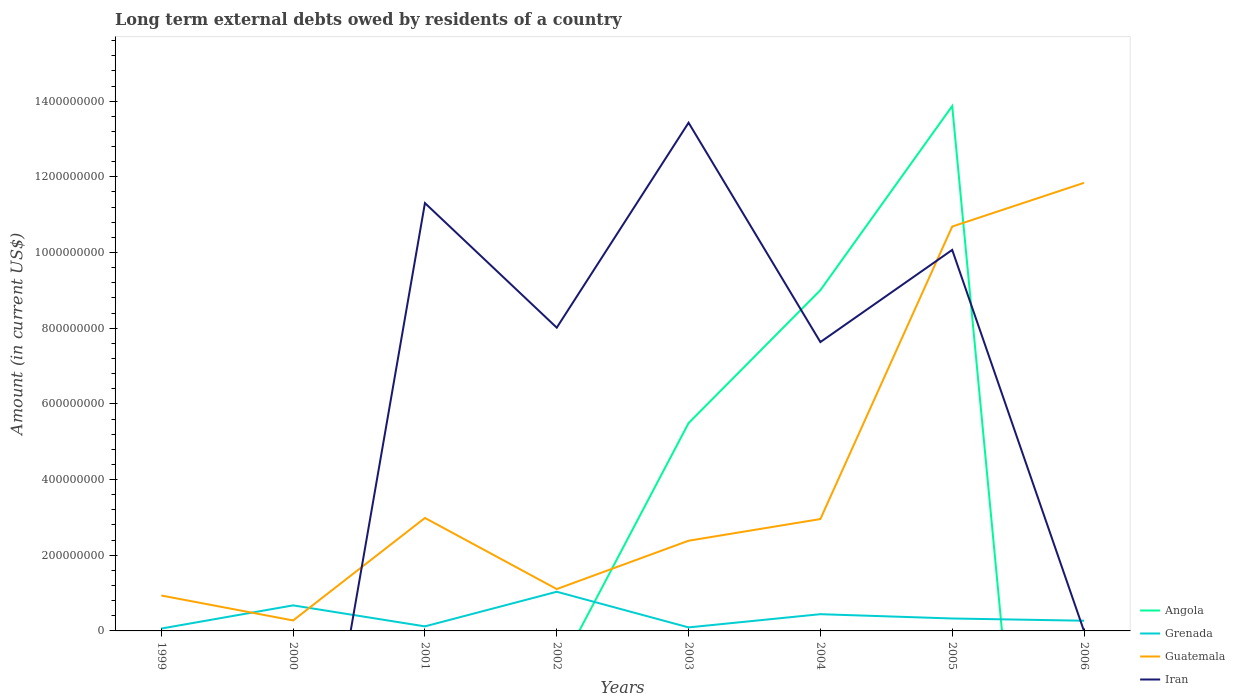Across all years, what is the maximum amount of long-term external debts owed by residents in Guatemala?
Your answer should be compact. 2.76e+07. What is the total amount of long-term external debts owed by residents in Iran in the graph?
Ensure brevity in your answer.  1.24e+08. What is the difference between the highest and the second highest amount of long-term external debts owed by residents in Guatemala?
Offer a very short reply. 1.16e+09. How many lines are there?
Your answer should be very brief. 4. How many years are there in the graph?
Offer a terse response. 8. Does the graph contain any zero values?
Ensure brevity in your answer.  Yes. How many legend labels are there?
Offer a very short reply. 4. How are the legend labels stacked?
Ensure brevity in your answer.  Vertical. What is the title of the graph?
Offer a terse response. Long term external debts owed by residents of a country. Does "Moldova" appear as one of the legend labels in the graph?
Your response must be concise. No. What is the label or title of the X-axis?
Your answer should be compact. Years. What is the label or title of the Y-axis?
Your answer should be compact. Amount (in current US$). What is the Amount (in current US$) of Angola in 1999?
Provide a succinct answer. 0. What is the Amount (in current US$) of Grenada in 1999?
Make the answer very short. 6.29e+06. What is the Amount (in current US$) in Guatemala in 1999?
Your answer should be very brief. 9.36e+07. What is the Amount (in current US$) in Iran in 1999?
Your answer should be compact. 0. What is the Amount (in current US$) of Angola in 2000?
Provide a succinct answer. 0. What is the Amount (in current US$) of Grenada in 2000?
Make the answer very short. 6.75e+07. What is the Amount (in current US$) in Guatemala in 2000?
Ensure brevity in your answer.  2.76e+07. What is the Amount (in current US$) in Iran in 2000?
Make the answer very short. 0. What is the Amount (in current US$) in Grenada in 2001?
Keep it short and to the point. 1.20e+07. What is the Amount (in current US$) of Guatemala in 2001?
Your answer should be very brief. 2.99e+08. What is the Amount (in current US$) in Iran in 2001?
Provide a succinct answer. 1.13e+09. What is the Amount (in current US$) in Grenada in 2002?
Provide a short and direct response. 1.04e+08. What is the Amount (in current US$) in Guatemala in 2002?
Give a very brief answer. 1.11e+08. What is the Amount (in current US$) of Iran in 2002?
Provide a succinct answer. 8.01e+08. What is the Amount (in current US$) in Angola in 2003?
Your answer should be very brief. 5.49e+08. What is the Amount (in current US$) in Grenada in 2003?
Provide a succinct answer. 9.30e+06. What is the Amount (in current US$) in Guatemala in 2003?
Provide a succinct answer. 2.38e+08. What is the Amount (in current US$) in Iran in 2003?
Your answer should be compact. 1.34e+09. What is the Amount (in current US$) in Angola in 2004?
Your response must be concise. 9.00e+08. What is the Amount (in current US$) in Grenada in 2004?
Make the answer very short. 4.42e+07. What is the Amount (in current US$) of Guatemala in 2004?
Your response must be concise. 2.96e+08. What is the Amount (in current US$) of Iran in 2004?
Offer a terse response. 7.63e+08. What is the Amount (in current US$) in Angola in 2005?
Your response must be concise. 1.39e+09. What is the Amount (in current US$) in Grenada in 2005?
Give a very brief answer. 3.29e+07. What is the Amount (in current US$) in Guatemala in 2005?
Offer a terse response. 1.07e+09. What is the Amount (in current US$) of Iran in 2005?
Your response must be concise. 1.01e+09. What is the Amount (in current US$) in Grenada in 2006?
Provide a short and direct response. 2.70e+07. What is the Amount (in current US$) in Guatemala in 2006?
Ensure brevity in your answer.  1.18e+09. What is the Amount (in current US$) in Iran in 2006?
Give a very brief answer. 0. Across all years, what is the maximum Amount (in current US$) of Angola?
Make the answer very short. 1.39e+09. Across all years, what is the maximum Amount (in current US$) of Grenada?
Offer a terse response. 1.04e+08. Across all years, what is the maximum Amount (in current US$) of Guatemala?
Your answer should be very brief. 1.18e+09. Across all years, what is the maximum Amount (in current US$) of Iran?
Make the answer very short. 1.34e+09. Across all years, what is the minimum Amount (in current US$) of Angola?
Offer a terse response. 0. Across all years, what is the minimum Amount (in current US$) in Grenada?
Ensure brevity in your answer.  6.29e+06. Across all years, what is the minimum Amount (in current US$) in Guatemala?
Offer a very short reply. 2.76e+07. Across all years, what is the minimum Amount (in current US$) of Iran?
Your response must be concise. 0. What is the total Amount (in current US$) of Angola in the graph?
Ensure brevity in your answer.  2.84e+09. What is the total Amount (in current US$) of Grenada in the graph?
Make the answer very short. 3.03e+08. What is the total Amount (in current US$) of Guatemala in the graph?
Ensure brevity in your answer.  3.32e+09. What is the total Amount (in current US$) of Iran in the graph?
Provide a succinct answer. 5.05e+09. What is the difference between the Amount (in current US$) of Grenada in 1999 and that in 2000?
Your answer should be compact. -6.12e+07. What is the difference between the Amount (in current US$) of Guatemala in 1999 and that in 2000?
Offer a terse response. 6.60e+07. What is the difference between the Amount (in current US$) of Grenada in 1999 and that in 2001?
Offer a terse response. -5.71e+06. What is the difference between the Amount (in current US$) in Guatemala in 1999 and that in 2001?
Your response must be concise. -2.05e+08. What is the difference between the Amount (in current US$) in Grenada in 1999 and that in 2002?
Keep it short and to the point. -9.72e+07. What is the difference between the Amount (in current US$) in Guatemala in 1999 and that in 2002?
Provide a succinct answer. -1.70e+07. What is the difference between the Amount (in current US$) in Grenada in 1999 and that in 2003?
Ensure brevity in your answer.  -3.01e+06. What is the difference between the Amount (in current US$) of Guatemala in 1999 and that in 2003?
Your answer should be compact. -1.45e+08. What is the difference between the Amount (in current US$) of Grenada in 1999 and that in 2004?
Provide a short and direct response. -3.79e+07. What is the difference between the Amount (in current US$) in Guatemala in 1999 and that in 2004?
Offer a terse response. -2.02e+08. What is the difference between the Amount (in current US$) in Grenada in 1999 and that in 2005?
Your answer should be very brief. -2.66e+07. What is the difference between the Amount (in current US$) of Guatemala in 1999 and that in 2005?
Keep it short and to the point. -9.75e+08. What is the difference between the Amount (in current US$) of Grenada in 1999 and that in 2006?
Provide a short and direct response. -2.07e+07. What is the difference between the Amount (in current US$) of Guatemala in 1999 and that in 2006?
Give a very brief answer. -1.09e+09. What is the difference between the Amount (in current US$) in Grenada in 2000 and that in 2001?
Your response must be concise. 5.55e+07. What is the difference between the Amount (in current US$) of Guatemala in 2000 and that in 2001?
Give a very brief answer. -2.71e+08. What is the difference between the Amount (in current US$) of Grenada in 2000 and that in 2002?
Your answer should be very brief. -3.60e+07. What is the difference between the Amount (in current US$) of Guatemala in 2000 and that in 2002?
Ensure brevity in your answer.  -8.30e+07. What is the difference between the Amount (in current US$) of Grenada in 2000 and that in 2003?
Your answer should be compact. 5.82e+07. What is the difference between the Amount (in current US$) in Guatemala in 2000 and that in 2003?
Ensure brevity in your answer.  -2.11e+08. What is the difference between the Amount (in current US$) in Grenada in 2000 and that in 2004?
Your answer should be compact. 2.33e+07. What is the difference between the Amount (in current US$) in Guatemala in 2000 and that in 2004?
Give a very brief answer. -2.68e+08. What is the difference between the Amount (in current US$) in Grenada in 2000 and that in 2005?
Provide a succinct answer. 3.46e+07. What is the difference between the Amount (in current US$) of Guatemala in 2000 and that in 2005?
Make the answer very short. -1.04e+09. What is the difference between the Amount (in current US$) in Grenada in 2000 and that in 2006?
Your answer should be very brief. 4.05e+07. What is the difference between the Amount (in current US$) of Guatemala in 2000 and that in 2006?
Provide a short and direct response. -1.16e+09. What is the difference between the Amount (in current US$) of Grenada in 2001 and that in 2002?
Your answer should be compact. -9.15e+07. What is the difference between the Amount (in current US$) in Guatemala in 2001 and that in 2002?
Provide a short and direct response. 1.88e+08. What is the difference between the Amount (in current US$) of Iran in 2001 and that in 2002?
Offer a very short reply. 3.29e+08. What is the difference between the Amount (in current US$) of Grenada in 2001 and that in 2003?
Offer a terse response. 2.70e+06. What is the difference between the Amount (in current US$) in Guatemala in 2001 and that in 2003?
Provide a succinct answer. 6.02e+07. What is the difference between the Amount (in current US$) in Iran in 2001 and that in 2003?
Offer a very short reply. -2.12e+08. What is the difference between the Amount (in current US$) of Grenada in 2001 and that in 2004?
Your answer should be compact. -3.22e+07. What is the difference between the Amount (in current US$) in Guatemala in 2001 and that in 2004?
Ensure brevity in your answer.  2.89e+06. What is the difference between the Amount (in current US$) in Iran in 2001 and that in 2004?
Give a very brief answer. 3.67e+08. What is the difference between the Amount (in current US$) in Grenada in 2001 and that in 2005?
Keep it short and to the point. -2.09e+07. What is the difference between the Amount (in current US$) in Guatemala in 2001 and that in 2005?
Offer a very short reply. -7.70e+08. What is the difference between the Amount (in current US$) in Iran in 2001 and that in 2005?
Your answer should be compact. 1.24e+08. What is the difference between the Amount (in current US$) in Grenada in 2001 and that in 2006?
Your answer should be compact. -1.50e+07. What is the difference between the Amount (in current US$) in Guatemala in 2001 and that in 2006?
Your response must be concise. -8.86e+08. What is the difference between the Amount (in current US$) of Grenada in 2002 and that in 2003?
Your answer should be compact. 9.42e+07. What is the difference between the Amount (in current US$) in Guatemala in 2002 and that in 2003?
Offer a terse response. -1.28e+08. What is the difference between the Amount (in current US$) in Iran in 2002 and that in 2003?
Your answer should be very brief. -5.42e+08. What is the difference between the Amount (in current US$) of Grenada in 2002 and that in 2004?
Provide a short and direct response. 5.93e+07. What is the difference between the Amount (in current US$) of Guatemala in 2002 and that in 2004?
Your response must be concise. -1.85e+08. What is the difference between the Amount (in current US$) of Iran in 2002 and that in 2004?
Your response must be concise. 3.81e+07. What is the difference between the Amount (in current US$) in Grenada in 2002 and that in 2005?
Ensure brevity in your answer.  7.07e+07. What is the difference between the Amount (in current US$) of Guatemala in 2002 and that in 2005?
Provide a short and direct response. -9.58e+08. What is the difference between the Amount (in current US$) in Iran in 2002 and that in 2005?
Ensure brevity in your answer.  -2.05e+08. What is the difference between the Amount (in current US$) in Grenada in 2002 and that in 2006?
Provide a succinct answer. 7.66e+07. What is the difference between the Amount (in current US$) in Guatemala in 2002 and that in 2006?
Make the answer very short. -1.07e+09. What is the difference between the Amount (in current US$) of Angola in 2003 and that in 2004?
Ensure brevity in your answer.  -3.51e+08. What is the difference between the Amount (in current US$) in Grenada in 2003 and that in 2004?
Ensure brevity in your answer.  -3.49e+07. What is the difference between the Amount (in current US$) of Guatemala in 2003 and that in 2004?
Ensure brevity in your answer.  -5.73e+07. What is the difference between the Amount (in current US$) in Iran in 2003 and that in 2004?
Provide a succinct answer. 5.80e+08. What is the difference between the Amount (in current US$) of Angola in 2003 and that in 2005?
Give a very brief answer. -8.38e+08. What is the difference between the Amount (in current US$) in Grenada in 2003 and that in 2005?
Offer a very short reply. -2.36e+07. What is the difference between the Amount (in current US$) of Guatemala in 2003 and that in 2005?
Provide a short and direct response. -8.30e+08. What is the difference between the Amount (in current US$) in Iran in 2003 and that in 2005?
Make the answer very short. 3.36e+08. What is the difference between the Amount (in current US$) of Grenada in 2003 and that in 2006?
Your response must be concise. -1.77e+07. What is the difference between the Amount (in current US$) of Guatemala in 2003 and that in 2006?
Ensure brevity in your answer.  -9.46e+08. What is the difference between the Amount (in current US$) of Angola in 2004 and that in 2005?
Offer a very short reply. -4.87e+08. What is the difference between the Amount (in current US$) in Grenada in 2004 and that in 2005?
Your answer should be compact. 1.14e+07. What is the difference between the Amount (in current US$) in Guatemala in 2004 and that in 2005?
Provide a succinct answer. -7.73e+08. What is the difference between the Amount (in current US$) of Iran in 2004 and that in 2005?
Provide a succinct answer. -2.44e+08. What is the difference between the Amount (in current US$) of Grenada in 2004 and that in 2006?
Provide a short and direct response. 1.73e+07. What is the difference between the Amount (in current US$) of Guatemala in 2004 and that in 2006?
Your answer should be very brief. -8.88e+08. What is the difference between the Amount (in current US$) of Grenada in 2005 and that in 2006?
Offer a terse response. 5.89e+06. What is the difference between the Amount (in current US$) of Guatemala in 2005 and that in 2006?
Your answer should be very brief. -1.16e+08. What is the difference between the Amount (in current US$) in Grenada in 1999 and the Amount (in current US$) in Guatemala in 2000?
Keep it short and to the point. -2.13e+07. What is the difference between the Amount (in current US$) of Grenada in 1999 and the Amount (in current US$) of Guatemala in 2001?
Your response must be concise. -2.92e+08. What is the difference between the Amount (in current US$) of Grenada in 1999 and the Amount (in current US$) of Iran in 2001?
Provide a succinct answer. -1.12e+09. What is the difference between the Amount (in current US$) in Guatemala in 1999 and the Amount (in current US$) in Iran in 2001?
Your response must be concise. -1.04e+09. What is the difference between the Amount (in current US$) of Grenada in 1999 and the Amount (in current US$) of Guatemala in 2002?
Provide a short and direct response. -1.04e+08. What is the difference between the Amount (in current US$) in Grenada in 1999 and the Amount (in current US$) in Iran in 2002?
Provide a short and direct response. -7.95e+08. What is the difference between the Amount (in current US$) of Guatemala in 1999 and the Amount (in current US$) of Iran in 2002?
Provide a succinct answer. -7.08e+08. What is the difference between the Amount (in current US$) of Grenada in 1999 and the Amount (in current US$) of Guatemala in 2003?
Make the answer very short. -2.32e+08. What is the difference between the Amount (in current US$) in Grenada in 1999 and the Amount (in current US$) in Iran in 2003?
Offer a very short reply. -1.34e+09. What is the difference between the Amount (in current US$) in Guatemala in 1999 and the Amount (in current US$) in Iran in 2003?
Your response must be concise. -1.25e+09. What is the difference between the Amount (in current US$) in Grenada in 1999 and the Amount (in current US$) in Guatemala in 2004?
Provide a short and direct response. -2.89e+08. What is the difference between the Amount (in current US$) in Grenada in 1999 and the Amount (in current US$) in Iran in 2004?
Keep it short and to the point. -7.57e+08. What is the difference between the Amount (in current US$) in Guatemala in 1999 and the Amount (in current US$) in Iran in 2004?
Ensure brevity in your answer.  -6.70e+08. What is the difference between the Amount (in current US$) of Grenada in 1999 and the Amount (in current US$) of Guatemala in 2005?
Make the answer very short. -1.06e+09. What is the difference between the Amount (in current US$) in Grenada in 1999 and the Amount (in current US$) in Iran in 2005?
Your answer should be very brief. -1.00e+09. What is the difference between the Amount (in current US$) of Guatemala in 1999 and the Amount (in current US$) of Iran in 2005?
Keep it short and to the point. -9.13e+08. What is the difference between the Amount (in current US$) of Grenada in 1999 and the Amount (in current US$) of Guatemala in 2006?
Keep it short and to the point. -1.18e+09. What is the difference between the Amount (in current US$) in Grenada in 2000 and the Amount (in current US$) in Guatemala in 2001?
Provide a short and direct response. -2.31e+08. What is the difference between the Amount (in current US$) in Grenada in 2000 and the Amount (in current US$) in Iran in 2001?
Make the answer very short. -1.06e+09. What is the difference between the Amount (in current US$) of Guatemala in 2000 and the Amount (in current US$) of Iran in 2001?
Give a very brief answer. -1.10e+09. What is the difference between the Amount (in current US$) of Grenada in 2000 and the Amount (in current US$) of Guatemala in 2002?
Give a very brief answer. -4.31e+07. What is the difference between the Amount (in current US$) in Grenada in 2000 and the Amount (in current US$) in Iran in 2002?
Ensure brevity in your answer.  -7.34e+08. What is the difference between the Amount (in current US$) in Guatemala in 2000 and the Amount (in current US$) in Iran in 2002?
Your answer should be very brief. -7.74e+08. What is the difference between the Amount (in current US$) in Grenada in 2000 and the Amount (in current US$) in Guatemala in 2003?
Your response must be concise. -1.71e+08. What is the difference between the Amount (in current US$) in Grenada in 2000 and the Amount (in current US$) in Iran in 2003?
Your answer should be very brief. -1.28e+09. What is the difference between the Amount (in current US$) of Guatemala in 2000 and the Amount (in current US$) of Iran in 2003?
Make the answer very short. -1.32e+09. What is the difference between the Amount (in current US$) of Grenada in 2000 and the Amount (in current US$) of Guatemala in 2004?
Give a very brief answer. -2.28e+08. What is the difference between the Amount (in current US$) of Grenada in 2000 and the Amount (in current US$) of Iran in 2004?
Provide a succinct answer. -6.96e+08. What is the difference between the Amount (in current US$) in Guatemala in 2000 and the Amount (in current US$) in Iran in 2004?
Your answer should be very brief. -7.36e+08. What is the difference between the Amount (in current US$) in Grenada in 2000 and the Amount (in current US$) in Guatemala in 2005?
Give a very brief answer. -1.00e+09. What is the difference between the Amount (in current US$) in Grenada in 2000 and the Amount (in current US$) in Iran in 2005?
Offer a very short reply. -9.39e+08. What is the difference between the Amount (in current US$) in Guatemala in 2000 and the Amount (in current US$) in Iran in 2005?
Offer a very short reply. -9.79e+08. What is the difference between the Amount (in current US$) of Grenada in 2000 and the Amount (in current US$) of Guatemala in 2006?
Your answer should be compact. -1.12e+09. What is the difference between the Amount (in current US$) of Grenada in 2001 and the Amount (in current US$) of Guatemala in 2002?
Give a very brief answer. -9.86e+07. What is the difference between the Amount (in current US$) of Grenada in 2001 and the Amount (in current US$) of Iran in 2002?
Ensure brevity in your answer.  -7.89e+08. What is the difference between the Amount (in current US$) in Guatemala in 2001 and the Amount (in current US$) in Iran in 2002?
Give a very brief answer. -5.03e+08. What is the difference between the Amount (in current US$) of Grenada in 2001 and the Amount (in current US$) of Guatemala in 2003?
Provide a succinct answer. -2.26e+08. What is the difference between the Amount (in current US$) of Grenada in 2001 and the Amount (in current US$) of Iran in 2003?
Keep it short and to the point. -1.33e+09. What is the difference between the Amount (in current US$) in Guatemala in 2001 and the Amount (in current US$) in Iran in 2003?
Provide a short and direct response. -1.04e+09. What is the difference between the Amount (in current US$) in Grenada in 2001 and the Amount (in current US$) in Guatemala in 2004?
Provide a succinct answer. -2.84e+08. What is the difference between the Amount (in current US$) in Grenada in 2001 and the Amount (in current US$) in Iran in 2004?
Offer a terse response. -7.51e+08. What is the difference between the Amount (in current US$) in Guatemala in 2001 and the Amount (in current US$) in Iran in 2004?
Make the answer very short. -4.65e+08. What is the difference between the Amount (in current US$) in Grenada in 2001 and the Amount (in current US$) in Guatemala in 2005?
Make the answer very short. -1.06e+09. What is the difference between the Amount (in current US$) of Grenada in 2001 and the Amount (in current US$) of Iran in 2005?
Your answer should be compact. -9.95e+08. What is the difference between the Amount (in current US$) in Guatemala in 2001 and the Amount (in current US$) in Iran in 2005?
Offer a terse response. -7.08e+08. What is the difference between the Amount (in current US$) of Grenada in 2001 and the Amount (in current US$) of Guatemala in 2006?
Provide a short and direct response. -1.17e+09. What is the difference between the Amount (in current US$) in Grenada in 2002 and the Amount (in current US$) in Guatemala in 2003?
Provide a short and direct response. -1.35e+08. What is the difference between the Amount (in current US$) of Grenada in 2002 and the Amount (in current US$) of Iran in 2003?
Ensure brevity in your answer.  -1.24e+09. What is the difference between the Amount (in current US$) of Guatemala in 2002 and the Amount (in current US$) of Iran in 2003?
Your response must be concise. -1.23e+09. What is the difference between the Amount (in current US$) in Grenada in 2002 and the Amount (in current US$) in Guatemala in 2004?
Give a very brief answer. -1.92e+08. What is the difference between the Amount (in current US$) in Grenada in 2002 and the Amount (in current US$) in Iran in 2004?
Provide a succinct answer. -6.60e+08. What is the difference between the Amount (in current US$) in Guatemala in 2002 and the Amount (in current US$) in Iran in 2004?
Your response must be concise. -6.53e+08. What is the difference between the Amount (in current US$) of Grenada in 2002 and the Amount (in current US$) of Guatemala in 2005?
Your answer should be very brief. -9.65e+08. What is the difference between the Amount (in current US$) of Grenada in 2002 and the Amount (in current US$) of Iran in 2005?
Provide a succinct answer. -9.03e+08. What is the difference between the Amount (in current US$) of Guatemala in 2002 and the Amount (in current US$) of Iran in 2005?
Provide a succinct answer. -8.96e+08. What is the difference between the Amount (in current US$) of Grenada in 2002 and the Amount (in current US$) of Guatemala in 2006?
Your answer should be compact. -1.08e+09. What is the difference between the Amount (in current US$) of Angola in 2003 and the Amount (in current US$) of Grenada in 2004?
Keep it short and to the point. 5.05e+08. What is the difference between the Amount (in current US$) of Angola in 2003 and the Amount (in current US$) of Guatemala in 2004?
Provide a succinct answer. 2.54e+08. What is the difference between the Amount (in current US$) in Angola in 2003 and the Amount (in current US$) in Iran in 2004?
Your answer should be compact. -2.14e+08. What is the difference between the Amount (in current US$) of Grenada in 2003 and the Amount (in current US$) of Guatemala in 2004?
Offer a very short reply. -2.86e+08. What is the difference between the Amount (in current US$) of Grenada in 2003 and the Amount (in current US$) of Iran in 2004?
Your answer should be compact. -7.54e+08. What is the difference between the Amount (in current US$) in Guatemala in 2003 and the Amount (in current US$) in Iran in 2004?
Your response must be concise. -5.25e+08. What is the difference between the Amount (in current US$) of Angola in 2003 and the Amount (in current US$) of Grenada in 2005?
Provide a short and direct response. 5.16e+08. What is the difference between the Amount (in current US$) in Angola in 2003 and the Amount (in current US$) in Guatemala in 2005?
Keep it short and to the point. -5.19e+08. What is the difference between the Amount (in current US$) of Angola in 2003 and the Amount (in current US$) of Iran in 2005?
Your answer should be compact. -4.58e+08. What is the difference between the Amount (in current US$) of Grenada in 2003 and the Amount (in current US$) of Guatemala in 2005?
Your answer should be compact. -1.06e+09. What is the difference between the Amount (in current US$) of Grenada in 2003 and the Amount (in current US$) of Iran in 2005?
Your response must be concise. -9.98e+08. What is the difference between the Amount (in current US$) of Guatemala in 2003 and the Amount (in current US$) of Iran in 2005?
Offer a terse response. -7.69e+08. What is the difference between the Amount (in current US$) in Angola in 2003 and the Amount (in current US$) in Grenada in 2006?
Give a very brief answer. 5.22e+08. What is the difference between the Amount (in current US$) in Angola in 2003 and the Amount (in current US$) in Guatemala in 2006?
Make the answer very short. -6.35e+08. What is the difference between the Amount (in current US$) in Grenada in 2003 and the Amount (in current US$) in Guatemala in 2006?
Provide a succinct answer. -1.17e+09. What is the difference between the Amount (in current US$) of Angola in 2004 and the Amount (in current US$) of Grenada in 2005?
Your answer should be compact. 8.68e+08. What is the difference between the Amount (in current US$) of Angola in 2004 and the Amount (in current US$) of Guatemala in 2005?
Ensure brevity in your answer.  -1.68e+08. What is the difference between the Amount (in current US$) in Angola in 2004 and the Amount (in current US$) in Iran in 2005?
Make the answer very short. -1.06e+08. What is the difference between the Amount (in current US$) of Grenada in 2004 and the Amount (in current US$) of Guatemala in 2005?
Keep it short and to the point. -1.02e+09. What is the difference between the Amount (in current US$) of Grenada in 2004 and the Amount (in current US$) of Iran in 2005?
Provide a succinct answer. -9.63e+08. What is the difference between the Amount (in current US$) of Guatemala in 2004 and the Amount (in current US$) of Iran in 2005?
Your answer should be compact. -7.11e+08. What is the difference between the Amount (in current US$) in Angola in 2004 and the Amount (in current US$) in Grenada in 2006?
Keep it short and to the point. 8.74e+08. What is the difference between the Amount (in current US$) in Angola in 2004 and the Amount (in current US$) in Guatemala in 2006?
Your response must be concise. -2.84e+08. What is the difference between the Amount (in current US$) of Grenada in 2004 and the Amount (in current US$) of Guatemala in 2006?
Your answer should be very brief. -1.14e+09. What is the difference between the Amount (in current US$) of Angola in 2005 and the Amount (in current US$) of Grenada in 2006?
Offer a very short reply. 1.36e+09. What is the difference between the Amount (in current US$) in Angola in 2005 and the Amount (in current US$) in Guatemala in 2006?
Ensure brevity in your answer.  2.03e+08. What is the difference between the Amount (in current US$) in Grenada in 2005 and the Amount (in current US$) in Guatemala in 2006?
Provide a succinct answer. -1.15e+09. What is the average Amount (in current US$) of Angola per year?
Your answer should be compact. 3.55e+08. What is the average Amount (in current US$) in Grenada per year?
Ensure brevity in your answer.  3.78e+07. What is the average Amount (in current US$) of Guatemala per year?
Provide a succinct answer. 4.15e+08. What is the average Amount (in current US$) of Iran per year?
Give a very brief answer. 6.31e+08. In the year 1999, what is the difference between the Amount (in current US$) in Grenada and Amount (in current US$) in Guatemala?
Offer a terse response. -8.73e+07. In the year 2000, what is the difference between the Amount (in current US$) of Grenada and Amount (in current US$) of Guatemala?
Offer a terse response. 3.99e+07. In the year 2001, what is the difference between the Amount (in current US$) of Grenada and Amount (in current US$) of Guatemala?
Your response must be concise. -2.87e+08. In the year 2001, what is the difference between the Amount (in current US$) of Grenada and Amount (in current US$) of Iran?
Give a very brief answer. -1.12e+09. In the year 2001, what is the difference between the Amount (in current US$) of Guatemala and Amount (in current US$) of Iran?
Your answer should be very brief. -8.32e+08. In the year 2002, what is the difference between the Amount (in current US$) of Grenada and Amount (in current US$) of Guatemala?
Your answer should be very brief. -7.08e+06. In the year 2002, what is the difference between the Amount (in current US$) in Grenada and Amount (in current US$) in Iran?
Keep it short and to the point. -6.98e+08. In the year 2002, what is the difference between the Amount (in current US$) in Guatemala and Amount (in current US$) in Iran?
Offer a terse response. -6.91e+08. In the year 2003, what is the difference between the Amount (in current US$) of Angola and Amount (in current US$) of Grenada?
Offer a terse response. 5.40e+08. In the year 2003, what is the difference between the Amount (in current US$) in Angola and Amount (in current US$) in Guatemala?
Your answer should be very brief. 3.11e+08. In the year 2003, what is the difference between the Amount (in current US$) in Angola and Amount (in current US$) in Iran?
Give a very brief answer. -7.94e+08. In the year 2003, what is the difference between the Amount (in current US$) in Grenada and Amount (in current US$) in Guatemala?
Your answer should be compact. -2.29e+08. In the year 2003, what is the difference between the Amount (in current US$) of Grenada and Amount (in current US$) of Iran?
Give a very brief answer. -1.33e+09. In the year 2003, what is the difference between the Amount (in current US$) in Guatemala and Amount (in current US$) in Iran?
Provide a succinct answer. -1.10e+09. In the year 2004, what is the difference between the Amount (in current US$) of Angola and Amount (in current US$) of Grenada?
Your answer should be very brief. 8.56e+08. In the year 2004, what is the difference between the Amount (in current US$) of Angola and Amount (in current US$) of Guatemala?
Give a very brief answer. 6.05e+08. In the year 2004, what is the difference between the Amount (in current US$) of Angola and Amount (in current US$) of Iran?
Provide a short and direct response. 1.37e+08. In the year 2004, what is the difference between the Amount (in current US$) of Grenada and Amount (in current US$) of Guatemala?
Make the answer very short. -2.51e+08. In the year 2004, what is the difference between the Amount (in current US$) of Grenada and Amount (in current US$) of Iran?
Your response must be concise. -7.19e+08. In the year 2004, what is the difference between the Amount (in current US$) of Guatemala and Amount (in current US$) of Iran?
Your response must be concise. -4.68e+08. In the year 2005, what is the difference between the Amount (in current US$) in Angola and Amount (in current US$) in Grenada?
Provide a succinct answer. 1.35e+09. In the year 2005, what is the difference between the Amount (in current US$) in Angola and Amount (in current US$) in Guatemala?
Offer a terse response. 3.18e+08. In the year 2005, what is the difference between the Amount (in current US$) of Angola and Amount (in current US$) of Iran?
Offer a terse response. 3.80e+08. In the year 2005, what is the difference between the Amount (in current US$) of Grenada and Amount (in current US$) of Guatemala?
Your response must be concise. -1.04e+09. In the year 2005, what is the difference between the Amount (in current US$) in Grenada and Amount (in current US$) in Iran?
Provide a short and direct response. -9.74e+08. In the year 2005, what is the difference between the Amount (in current US$) in Guatemala and Amount (in current US$) in Iran?
Make the answer very short. 6.17e+07. In the year 2006, what is the difference between the Amount (in current US$) in Grenada and Amount (in current US$) in Guatemala?
Keep it short and to the point. -1.16e+09. What is the ratio of the Amount (in current US$) of Grenada in 1999 to that in 2000?
Ensure brevity in your answer.  0.09. What is the ratio of the Amount (in current US$) of Guatemala in 1999 to that in 2000?
Your answer should be compact. 3.39. What is the ratio of the Amount (in current US$) of Grenada in 1999 to that in 2001?
Offer a very short reply. 0.52. What is the ratio of the Amount (in current US$) of Guatemala in 1999 to that in 2001?
Ensure brevity in your answer.  0.31. What is the ratio of the Amount (in current US$) of Grenada in 1999 to that in 2002?
Give a very brief answer. 0.06. What is the ratio of the Amount (in current US$) in Guatemala in 1999 to that in 2002?
Give a very brief answer. 0.85. What is the ratio of the Amount (in current US$) in Grenada in 1999 to that in 2003?
Offer a very short reply. 0.68. What is the ratio of the Amount (in current US$) of Guatemala in 1999 to that in 2003?
Provide a short and direct response. 0.39. What is the ratio of the Amount (in current US$) in Grenada in 1999 to that in 2004?
Keep it short and to the point. 0.14. What is the ratio of the Amount (in current US$) in Guatemala in 1999 to that in 2004?
Your answer should be compact. 0.32. What is the ratio of the Amount (in current US$) in Grenada in 1999 to that in 2005?
Provide a short and direct response. 0.19. What is the ratio of the Amount (in current US$) in Guatemala in 1999 to that in 2005?
Make the answer very short. 0.09. What is the ratio of the Amount (in current US$) in Grenada in 1999 to that in 2006?
Your response must be concise. 0.23. What is the ratio of the Amount (in current US$) of Guatemala in 1999 to that in 2006?
Make the answer very short. 0.08. What is the ratio of the Amount (in current US$) in Grenada in 2000 to that in 2001?
Offer a very short reply. 5.63. What is the ratio of the Amount (in current US$) in Guatemala in 2000 to that in 2001?
Your answer should be very brief. 0.09. What is the ratio of the Amount (in current US$) of Grenada in 2000 to that in 2002?
Your answer should be very brief. 0.65. What is the ratio of the Amount (in current US$) in Guatemala in 2000 to that in 2002?
Make the answer very short. 0.25. What is the ratio of the Amount (in current US$) in Grenada in 2000 to that in 2003?
Ensure brevity in your answer.  7.26. What is the ratio of the Amount (in current US$) of Guatemala in 2000 to that in 2003?
Your answer should be very brief. 0.12. What is the ratio of the Amount (in current US$) of Grenada in 2000 to that in 2004?
Ensure brevity in your answer.  1.53. What is the ratio of the Amount (in current US$) of Guatemala in 2000 to that in 2004?
Your answer should be very brief. 0.09. What is the ratio of the Amount (in current US$) of Grenada in 2000 to that in 2005?
Provide a succinct answer. 2.05. What is the ratio of the Amount (in current US$) of Guatemala in 2000 to that in 2005?
Give a very brief answer. 0.03. What is the ratio of the Amount (in current US$) in Grenada in 2000 to that in 2006?
Make the answer very short. 2.5. What is the ratio of the Amount (in current US$) of Guatemala in 2000 to that in 2006?
Your answer should be compact. 0.02. What is the ratio of the Amount (in current US$) of Grenada in 2001 to that in 2002?
Your answer should be very brief. 0.12. What is the ratio of the Amount (in current US$) in Guatemala in 2001 to that in 2002?
Give a very brief answer. 2.7. What is the ratio of the Amount (in current US$) of Iran in 2001 to that in 2002?
Make the answer very short. 1.41. What is the ratio of the Amount (in current US$) of Grenada in 2001 to that in 2003?
Make the answer very short. 1.29. What is the ratio of the Amount (in current US$) in Guatemala in 2001 to that in 2003?
Keep it short and to the point. 1.25. What is the ratio of the Amount (in current US$) of Iran in 2001 to that in 2003?
Offer a very short reply. 0.84. What is the ratio of the Amount (in current US$) of Grenada in 2001 to that in 2004?
Your response must be concise. 0.27. What is the ratio of the Amount (in current US$) of Guatemala in 2001 to that in 2004?
Make the answer very short. 1.01. What is the ratio of the Amount (in current US$) of Iran in 2001 to that in 2004?
Offer a very short reply. 1.48. What is the ratio of the Amount (in current US$) in Grenada in 2001 to that in 2005?
Your response must be concise. 0.37. What is the ratio of the Amount (in current US$) in Guatemala in 2001 to that in 2005?
Provide a succinct answer. 0.28. What is the ratio of the Amount (in current US$) of Iran in 2001 to that in 2005?
Provide a short and direct response. 1.12. What is the ratio of the Amount (in current US$) of Grenada in 2001 to that in 2006?
Your answer should be very brief. 0.44. What is the ratio of the Amount (in current US$) of Guatemala in 2001 to that in 2006?
Give a very brief answer. 0.25. What is the ratio of the Amount (in current US$) in Grenada in 2002 to that in 2003?
Make the answer very short. 11.13. What is the ratio of the Amount (in current US$) in Guatemala in 2002 to that in 2003?
Make the answer very short. 0.46. What is the ratio of the Amount (in current US$) of Iran in 2002 to that in 2003?
Your answer should be very brief. 0.6. What is the ratio of the Amount (in current US$) of Grenada in 2002 to that in 2004?
Your response must be concise. 2.34. What is the ratio of the Amount (in current US$) of Guatemala in 2002 to that in 2004?
Make the answer very short. 0.37. What is the ratio of the Amount (in current US$) of Iran in 2002 to that in 2004?
Make the answer very short. 1.05. What is the ratio of the Amount (in current US$) of Grenada in 2002 to that in 2005?
Make the answer very short. 3.15. What is the ratio of the Amount (in current US$) in Guatemala in 2002 to that in 2005?
Ensure brevity in your answer.  0.1. What is the ratio of the Amount (in current US$) in Iran in 2002 to that in 2005?
Offer a very short reply. 0.8. What is the ratio of the Amount (in current US$) of Grenada in 2002 to that in 2006?
Offer a very short reply. 3.84. What is the ratio of the Amount (in current US$) in Guatemala in 2002 to that in 2006?
Provide a short and direct response. 0.09. What is the ratio of the Amount (in current US$) in Angola in 2003 to that in 2004?
Give a very brief answer. 0.61. What is the ratio of the Amount (in current US$) in Grenada in 2003 to that in 2004?
Your response must be concise. 0.21. What is the ratio of the Amount (in current US$) of Guatemala in 2003 to that in 2004?
Your answer should be compact. 0.81. What is the ratio of the Amount (in current US$) of Iran in 2003 to that in 2004?
Your response must be concise. 1.76. What is the ratio of the Amount (in current US$) in Angola in 2003 to that in 2005?
Make the answer very short. 0.4. What is the ratio of the Amount (in current US$) of Grenada in 2003 to that in 2005?
Provide a short and direct response. 0.28. What is the ratio of the Amount (in current US$) in Guatemala in 2003 to that in 2005?
Your response must be concise. 0.22. What is the ratio of the Amount (in current US$) in Iran in 2003 to that in 2005?
Your answer should be very brief. 1.33. What is the ratio of the Amount (in current US$) in Grenada in 2003 to that in 2006?
Give a very brief answer. 0.34. What is the ratio of the Amount (in current US$) in Guatemala in 2003 to that in 2006?
Your answer should be very brief. 0.2. What is the ratio of the Amount (in current US$) of Angola in 2004 to that in 2005?
Offer a terse response. 0.65. What is the ratio of the Amount (in current US$) in Grenada in 2004 to that in 2005?
Your response must be concise. 1.35. What is the ratio of the Amount (in current US$) in Guatemala in 2004 to that in 2005?
Your answer should be compact. 0.28. What is the ratio of the Amount (in current US$) of Iran in 2004 to that in 2005?
Your response must be concise. 0.76. What is the ratio of the Amount (in current US$) of Grenada in 2004 to that in 2006?
Provide a short and direct response. 1.64. What is the ratio of the Amount (in current US$) of Guatemala in 2004 to that in 2006?
Your response must be concise. 0.25. What is the ratio of the Amount (in current US$) of Grenada in 2005 to that in 2006?
Your answer should be very brief. 1.22. What is the ratio of the Amount (in current US$) in Guatemala in 2005 to that in 2006?
Keep it short and to the point. 0.9. What is the difference between the highest and the second highest Amount (in current US$) in Angola?
Your response must be concise. 4.87e+08. What is the difference between the highest and the second highest Amount (in current US$) in Grenada?
Make the answer very short. 3.60e+07. What is the difference between the highest and the second highest Amount (in current US$) in Guatemala?
Offer a very short reply. 1.16e+08. What is the difference between the highest and the second highest Amount (in current US$) of Iran?
Your response must be concise. 2.12e+08. What is the difference between the highest and the lowest Amount (in current US$) in Angola?
Your response must be concise. 1.39e+09. What is the difference between the highest and the lowest Amount (in current US$) in Grenada?
Your response must be concise. 9.72e+07. What is the difference between the highest and the lowest Amount (in current US$) of Guatemala?
Your response must be concise. 1.16e+09. What is the difference between the highest and the lowest Amount (in current US$) of Iran?
Keep it short and to the point. 1.34e+09. 